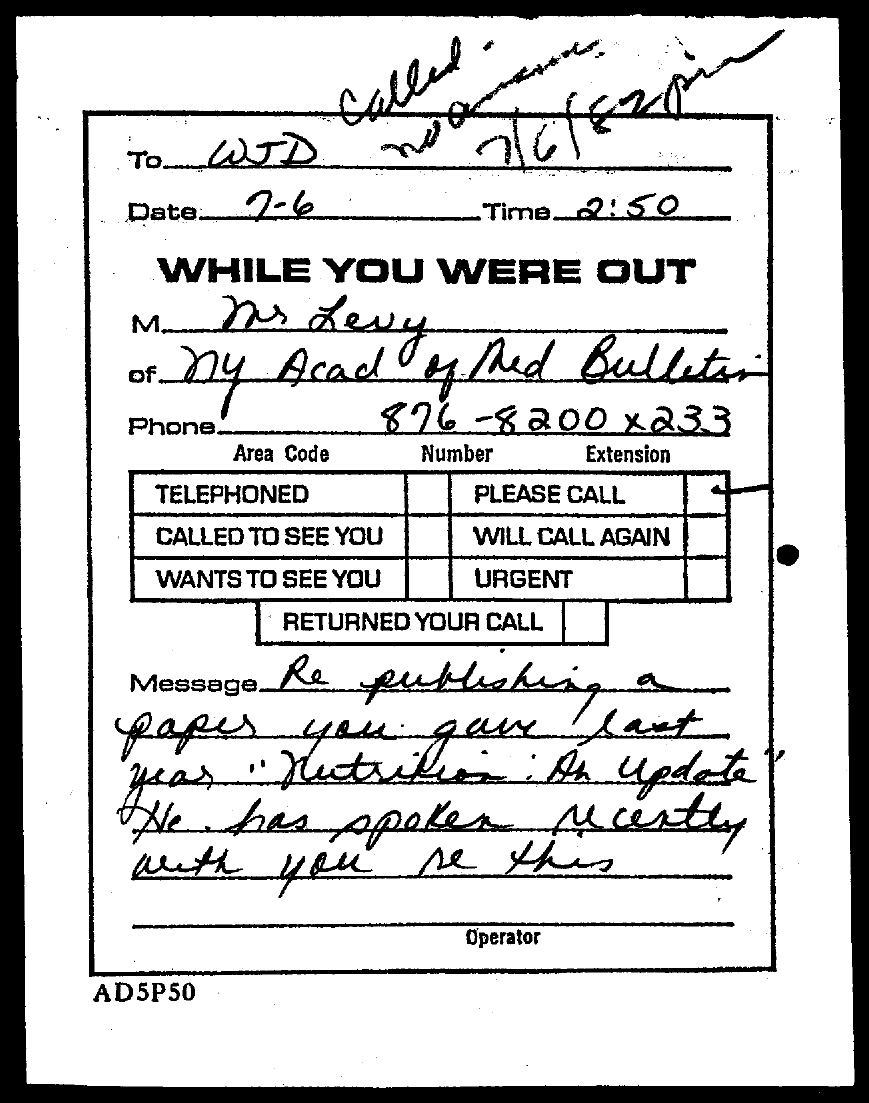What is the date mentioned in the document?
Offer a terse response. 7-6. What is the time mentioned in the document?
Provide a short and direct response. 2:50. 